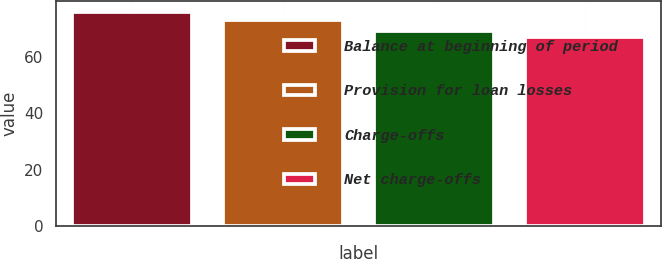<chart> <loc_0><loc_0><loc_500><loc_500><bar_chart><fcel>Balance at beginning of period<fcel>Provision for loan losses<fcel>Charge-offs<fcel>Net charge-offs<nl><fcel>76<fcel>73<fcel>69<fcel>67<nl></chart> 